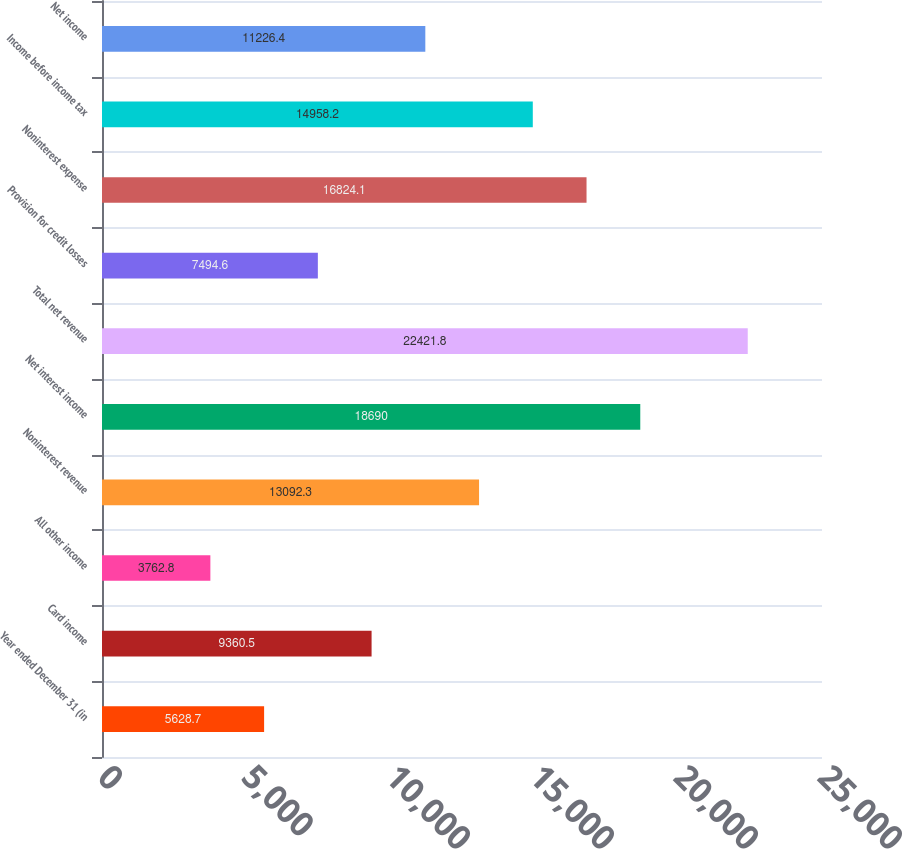<chart> <loc_0><loc_0><loc_500><loc_500><bar_chart><fcel>Year ended December 31 (in<fcel>Card income<fcel>All other income<fcel>Noninterest revenue<fcel>Net interest income<fcel>Total net revenue<fcel>Provision for credit losses<fcel>Noninterest expense<fcel>Income before income tax<fcel>Net income<nl><fcel>5628.7<fcel>9360.5<fcel>3762.8<fcel>13092.3<fcel>18690<fcel>22421.8<fcel>7494.6<fcel>16824.1<fcel>14958.2<fcel>11226.4<nl></chart> 